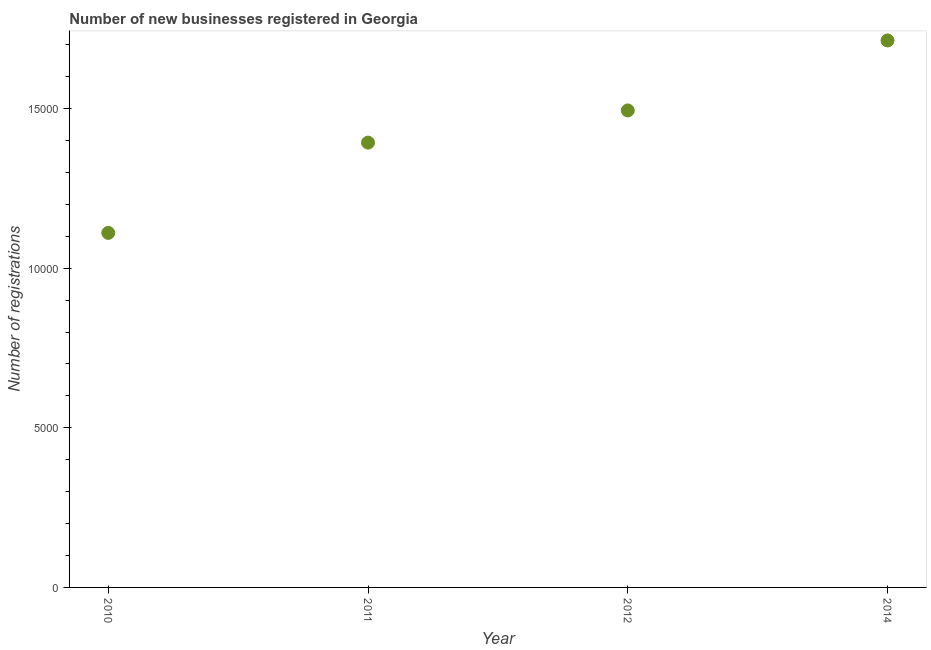What is the number of new business registrations in 2011?
Your answer should be very brief. 1.39e+04. Across all years, what is the maximum number of new business registrations?
Your answer should be compact. 1.71e+04. Across all years, what is the minimum number of new business registrations?
Your response must be concise. 1.11e+04. In which year was the number of new business registrations maximum?
Keep it short and to the point. 2014. In which year was the number of new business registrations minimum?
Give a very brief answer. 2010. What is the sum of the number of new business registrations?
Provide a short and direct response. 5.71e+04. What is the difference between the number of new business registrations in 2011 and 2014?
Provide a short and direct response. -3201. What is the average number of new business registrations per year?
Keep it short and to the point. 1.43e+04. What is the median number of new business registrations?
Offer a very short reply. 1.44e+04. What is the ratio of the number of new business registrations in 2010 to that in 2014?
Your answer should be very brief. 0.65. Is the difference between the number of new business registrations in 2010 and 2012 greater than the difference between any two years?
Your response must be concise. No. What is the difference between the highest and the second highest number of new business registrations?
Make the answer very short. 2193. What is the difference between the highest and the lowest number of new business registrations?
Provide a succinct answer. 6029. How many dotlines are there?
Provide a short and direct response. 1. How many years are there in the graph?
Ensure brevity in your answer.  4. Does the graph contain any zero values?
Offer a terse response. No. What is the title of the graph?
Give a very brief answer. Number of new businesses registered in Georgia. What is the label or title of the Y-axis?
Your answer should be compact. Number of registrations. What is the Number of registrations in 2010?
Ensure brevity in your answer.  1.11e+04. What is the Number of registrations in 2011?
Offer a very short reply. 1.39e+04. What is the Number of registrations in 2012?
Your response must be concise. 1.49e+04. What is the Number of registrations in 2014?
Your answer should be very brief. 1.71e+04. What is the difference between the Number of registrations in 2010 and 2011?
Keep it short and to the point. -2828. What is the difference between the Number of registrations in 2010 and 2012?
Give a very brief answer. -3836. What is the difference between the Number of registrations in 2010 and 2014?
Give a very brief answer. -6029. What is the difference between the Number of registrations in 2011 and 2012?
Your response must be concise. -1008. What is the difference between the Number of registrations in 2011 and 2014?
Your answer should be very brief. -3201. What is the difference between the Number of registrations in 2012 and 2014?
Your answer should be very brief. -2193. What is the ratio of the Number of registrations in 2010 to that in 2011?
Your answer should be compact. 0.8. What is the ratio of the Number of registrations in 2010 to that in 2012?
Give a very brief answer. 0.74. What is the ratio of the Number of registrations in 2010 to that in 2014?
Keep it short and to the point. 0.65. What is the ratio of the Number of registrations in 2011 to that in 2012?
Offer a very short reply. 0.93. What is the ratio of the Number of registrations in 2011 to that in 2014?
Your response must be concise. 0.81. What is the ratio of the Number of registrations in 2012 to that in 2014?
Your answer should be compact. 0.87. 